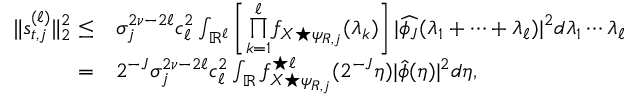<formula> <loc_0><loc_0><loc_500><loc_500>\begin{array} { r l } { \| s _ { t , j } ^ { ( \ell ) } \| _ { 2 } ^ { 2 } \leq } & { \sigma _ { j } ^ { 2 \nu - 2 \ell } c _ { \ell } ^ { 2 } \int _ { \mathbb { R } ^ { \ell } } \left [ \overset { \ell } { \underset { k = 1 } { \prod } } f _ { X ^ { * } \psi _ { R , j } } ( \lambda _ { k } ) \right ] | \widehat { \phi _ { J } } ( \lambda _ { 1 } + \cdots + \lambda _ { \ell } ) | ^ { 2 } d \lambda _ { 1 } \cdots \lambda _ { \ell } } \\ { = } & { 2 ^ { - J } \sigma _ { j } ^ { 2 \nu - 2 \ell } c _ { \ell } ^ { 2 } \int _ { \mathbb { R } } f _ { X ^ { * } \psi _ { R , j } } ^ { ^ { * } \ell } ( 2 ^ { - J } \eta ) | \widehat { \phi } ( \eta ) | ^ { 2 } d \eta , } \end{array}</formula> 